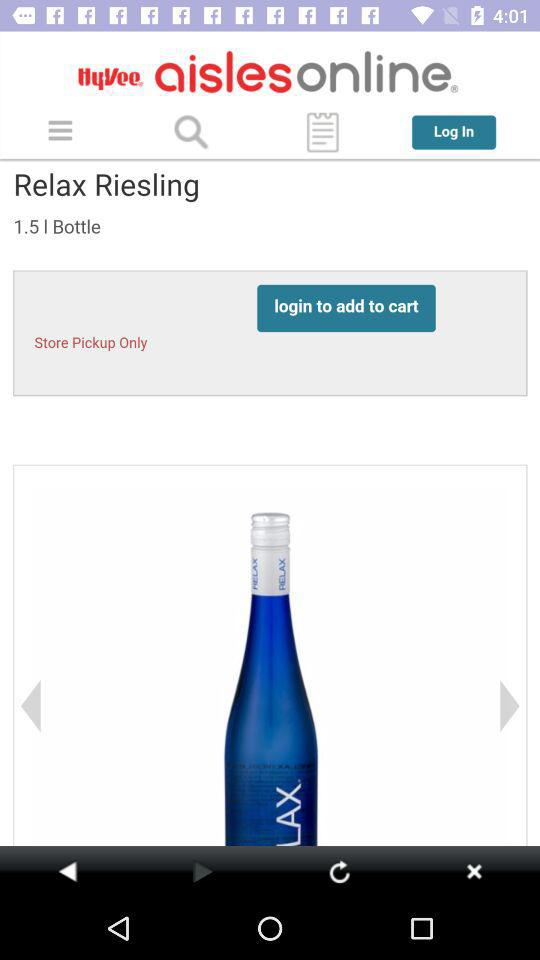What is the app name? The app name is "Hy-Vee aisles online". 